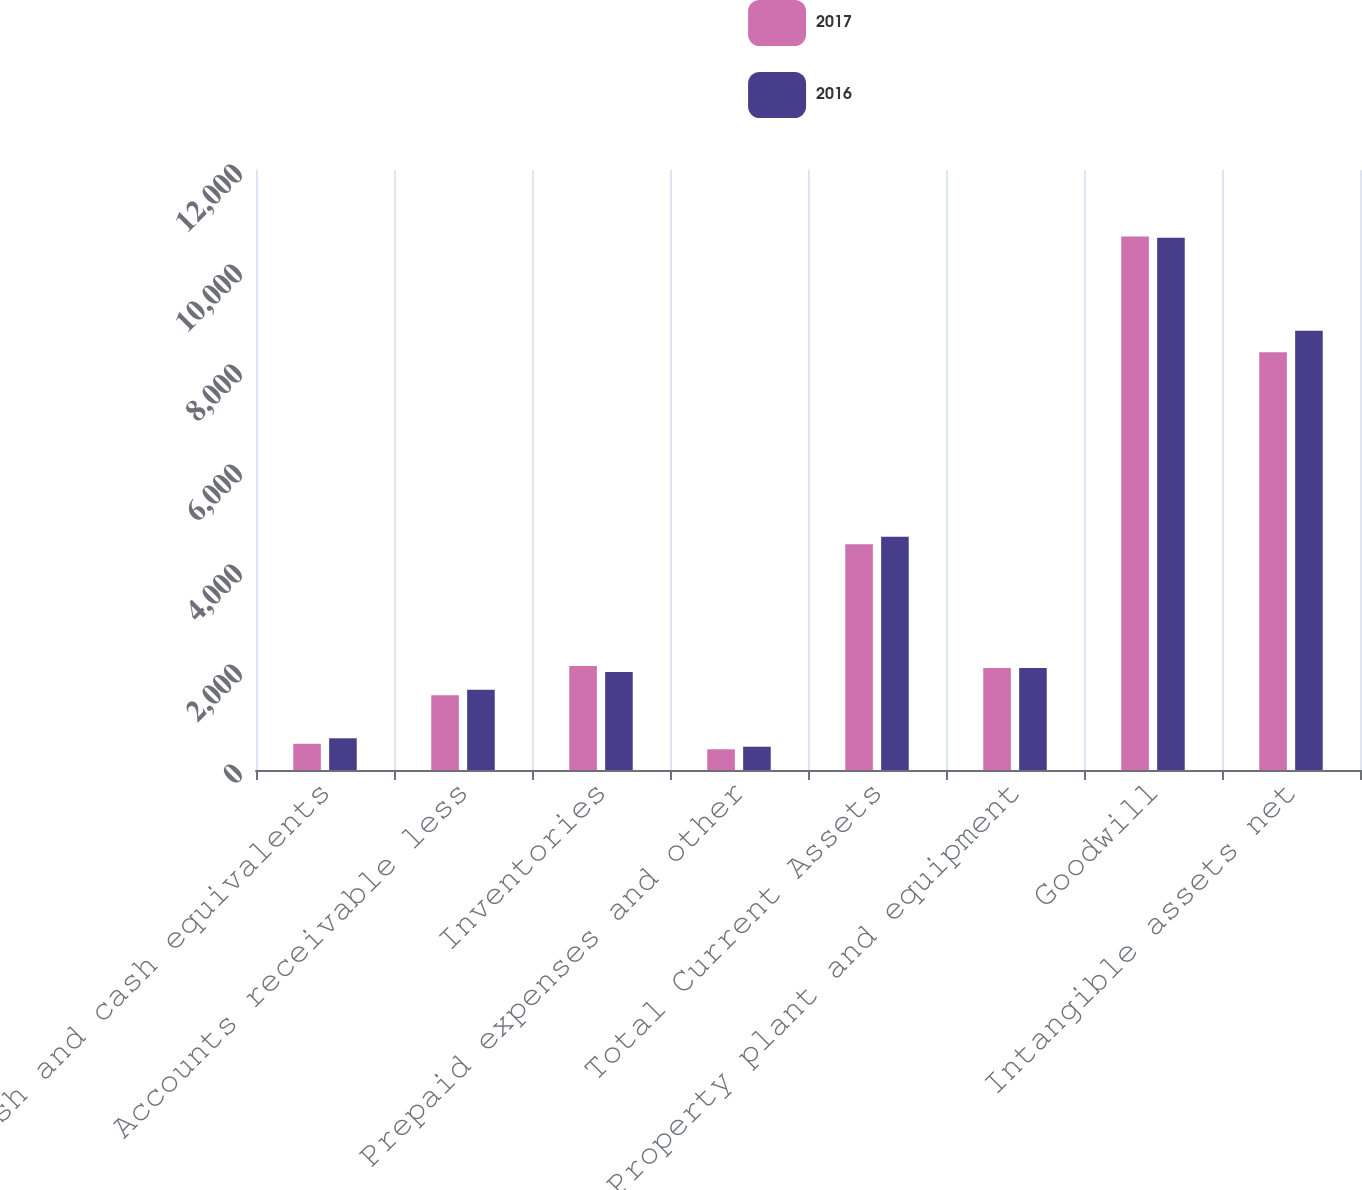Convert chart. <chart><loc_0><loc_0><loc_500><loc_500><stacked_bar_chart><ecel><fcel>Cash and cash equivalents<fcel>Accounts receivable less<fcel>Inventories<fcel>Prepaid expenses and other<fcel>Total Current Assets<fcel>Property plant and equipment<fcel>Goodwill<fcel>Intangible assets net<nl><fcel>2017<fcel>524.4<fcel>1494.6<fcel>2081.8<fcel>414.5<fcel>4515.3<fcel>2038.6<fcel>10668.4<fcel>8353.4<nl><fcel>2016<fcel>634.1<fcel>1604.4<fcel>1959.4<fcel>465.7<fcel>4663.6<fcel>2037.9<fcel>10643.9<fcel>8785.4<nl></chart> 